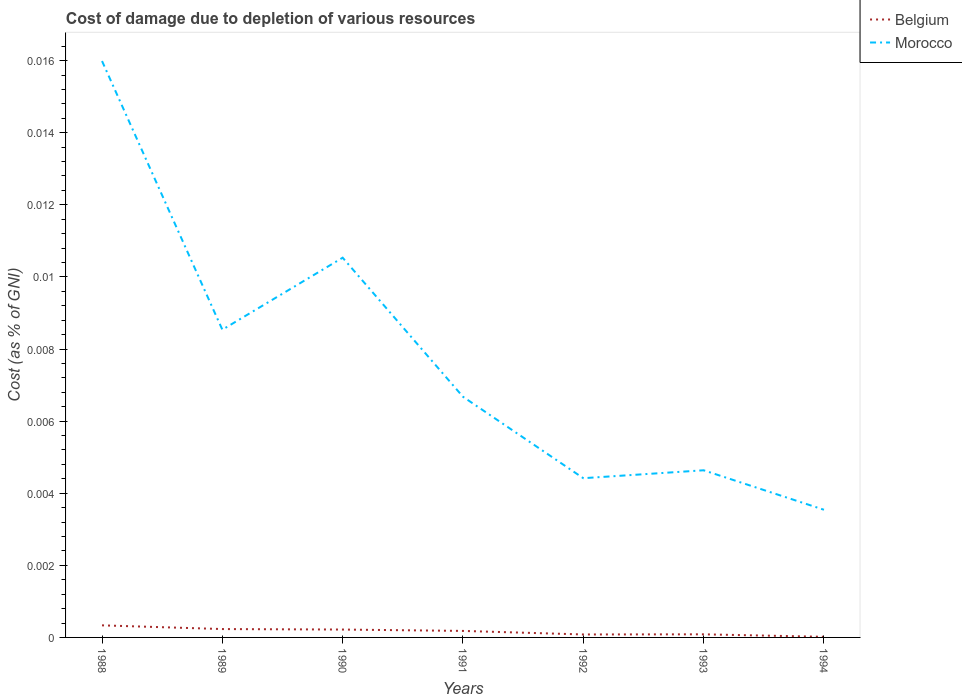Across all years, what is the maximum cost of damage caused due to the depletion of various resources in Belgium?
Provide a succinct answer. 1.66630783874537e-5. What is the total cost of damage caused due to the depletion of various resources in Morocco in the graph?
Give a very brief answer. 0. What is the difference between the highest and the second highest cost of damage caused due to the depletion of various resources in Belgium?
Keep it short and to the point. 0. What is the difference between the highest and the lowest cost of damage caused due to the depletion of various resources in Morocco?
Provide a succinct answer. 3. What is the difference between two consecutive major ticks on the Y-axis?
Offer a very short reply. 0. Does the graph contain any zero values?
Your response must be concise. No. Where does the legend appear in the graph?
Ensure brevity in your answer.  Top right. What is the title of the graph?
Ensure brevity in your answer.  Cost of damage due to depletion of various resources. Does "Zimbabwe" appear as one of the legend labels in the graph?
Ensure brevity in your answer.  No. What is the label or title of the X-axis?
Keep it short and to the point. Years. What is the label or title of the Y-axis?
Provide a short and direct response. Cost (as % of GNI). What is the Cost (as % of GNI) of Belgium in 1988?
Provide a succinct answer. 0. What is the Cost (as % of GNI) of Morocco in 1988?
Keep it short and to the point. 0.02. What is the Cost (as % of GNI) of Belgium in 1989?
Ensure brevity in your answer.  0. What is the Cost (as % of GNI) of Morocco in 1989?
Provide a succinct answer. 0.01. What is the Cost (as % of GNI) in Belgium in 1990?
Offer a very short reply. 0. What is the Cost (as % of GNI) of Morocco in 1990?
Keep it short and to the point. 0.01. What is the Cost (as % of GNI) in Belgium in 1991?
Offer a terse response. 0. What is the Cost (as % of GNI) in Morocco in 1991?
Ensure brevity in your answer.  0.01. What is the Cost (as % of GNI) in Belgium in 1992?
Your answer should be very brief. 8.21367051820707e-5. What is the Cost (as % of GNI) of Morocco in 1992?
Make the answer very short. 0. What is the Cost (as % of GNI) in Belgium in 1993?
Your response must be concise. 8.605214522011529e-5. What is the Cost (as % of GNI) of Morocco in 1993?
Your answer should be very brief. 0. What is the Cost (as % of GNI) of Belgium in 1994?
Make the answer very short. 1.66630783874537e-5. What is the Cost (as % of GNI) in Morocco in 1994?
Offer a very short reply. 0. Across all years, what is the maximum Cost (as % of GNI) in Belgium?
Give a very brief answer. 0. Across all years, what is the maximum Cost (as % of GNI) of Morocco?
Give a very brief answer. 0.02. Across all years, what is the minimum Cost (as % of GNI) in Belgium?
Keep it short and to the point. 1.66630783874537e-5. Across all years, what is the minimum Cost (as % of GNI) in Morocco?
Make the answer very short. 0. What is the total Cost (as % of GNI) in Belgium in the graph?
Your answer should be very brief. 0. What is the total Cost (as % of GNI) in Morocco in the graph?
Make the answer very short. 0.05. What is the difference between the Cost (as % of GNI) of Belgium in 1988 and that in 1989?
Offer a very short reply. 0. What is the difference between the Cost (as % of GNI) of Morocco in 1988 and that in 1989?
Your answer should be very brief. 0.01. What is the difference between the Cost (as % of GNI) of Morocco in 1988 and that in 1990?
Offer a very short reply. 0.01. What is the difference between the Cost (as % of GNI) in Belgium in 1988 and that in 1991?
Offer a very short reply. 0. What is the difference between the Cost (as % of GNI) of Morocco in 1988 and that in 1991?
Ensure brevity in your answer.  0.01. What is the difference between the Cost (as % of GNI) of Belgium in 1988 and that in 1992?
Your response must be concise. 0. What is the difference between the Cost (as % of GNI) in Morocco in 1988 and that in 1992?
Provide a succinct answer. 0.01. What is the difference between the Cost (as % of GNI) in Belgium in 1988 and that in 1993?
Offer a terse response. 0. What is the difference between the Cost (as % of GNI) of Morocco in 1988 and that in 1993?
Give a very brief answer. 0.01. What is the difference between the Cost (as % of GNI) in Morocco in 1988 and that in 1994?
Make the answer very short. 0.01. What is the difference between the Cost (as % of GNI) in Belgium in 1989 and that in 1990?
Keep it short and to the point. 0. What is the difference between the Cost (as % of GNI) of Morocco in 1989 and that in 1990?
Offer a terse response. -0. What is the difference between the Cost (as % of GNI) in Belgium in 1989 and that in 1991?
Offer a very short reply. 0. What is the difference between the Cost (as % of GNI) of Morocco in 1989 and that in 1991?
Offer a very short reply. 0. What is the difference between the Cost (as % of GNI) of Morocco in 1989 and that in 1992?
Offer a terse response. 0. What is the difference between the Cost (as % of GNI) in Belgium in 1989 and that in 1993?
Give a very brief answer. 0. What is the difference between the Cost (as % of GNI) of Morocco in 1989 and that in 1993?
Ensure brevity in your answer.  0. What is the difference between the Cost (as % of GNI) of Belgium in 1989 and that in 1994?
Keep it short and to the point. 0. What is the difference between the Cost (as % of GNI) in Morocco in 1989 and that in 1994?
Offer a very short reply. 0.01. What is the difference between the Cost (as % of GNI) in Morocco in 1990 and that in 1991?
Offer a terse response. 0. What is the difference between the Cost (as % of GNI) in Belgium in 1990 and that in 1992?
Make the answer very short. 0. What is the difference between the Cost (as % of GNI) in Morocco in 1990 and that in 1992?
Offer a terse response. 0.01. What is the difference between the Cost (as % of GNI) of Morocco in 1990 and that in 1993?
Your answer should be very brief. 0.01. What is the difference between the Cost (as % of GNI) of Morocco in 1990 and that in 1994?
Your answer should be compact. 0.01. What is the difference between the Cost (as % of GNI) in Belgium in 1991 and that in 1992?
Your response must be concise. 0. What is the difference between the Cost (as % of GNI) in Morocco in 1991 and that in 1992?
Your response must be concise. 0. What is the difference between the Cost (as % of GNI) of Belgium in 1991 and that in 1993?
Ensure brevity in your answer.  0. What is the difference between the Cost (as % of GNI) of Morocco in 1991 and that in 1993?
Your answer should be very brief. 0. What is the difference between the Cost (as % of GNI) in Belgium in 1991 and that in 1994?
Provide a short and direct response. 0. What is the difference between the Cost (as % of GNI) of Morocco in 1991 and that in 1994?
Ensure brevity in your answer.  0. What is the difference between the Cost (as % of GNI) in Morocco in 1992 and that in 1993?
Provide a succinct answer. -0. What is the difference between the Cost (as % of GNI) of Morocco in 1992 and that in 1994?
Provide a succinct answer. 0. What is the difference between the Cost (as % of GNI) in Belgium in 1993 and that in 1994?
Keep it short and to the point. 0. What is the difference between the Cost (as % of GNI) in Morocco in 1993 and that in 1994?
Ensure brevity in your answer.  0. What is the difference between the Cost (as % of GNI) of Belgium in 1988 and the Cost (as % of GNI) of Morocco in 1989?
Give a very brief answer. -0.01. What is the difference between the Cost (as % of GNI) of Belgium in 1988 and the Cost (as % of GNI) of Morocco in 1990?
Provide a succinct answer. -0.01. What is the difference between the Cost (as % of GNI) of Belgium in 1988 and the Cost (as % of GNI) of Morocco in 1991?
Offer a very short reply. -0.01. What is the difference between the Cost (as % of GNI) in Belgium in 1988 and the Cost (as % of GNI) in Morocco in 1992?
Ensure brevity in your answer.  -0. What is the difference between the Cost (as % of GNI) of Belgium in 1988 and the Cost (as % of GNI) of Morocco in 1993?
Provide a succinct answer. -0. What is the difference between the Cost (as % of GNI) in Belgium in 1988 and the Cost (as % of GNI) in Morocco in 1994?
Offer a very short reply. -0. What is the difference between the Cost (as % of GNI) in Belgium in 1989 and the Cost (as % of GNI) in Morocco in 1990?
Offer a very short reply. -0.01. What is the difference between the Cost (as % of GNI) in Belgium in 1989 and the Cost (as % of GNI) in Morocco in 1991?
Your answer should be compact. -0.01. What is the difference between the Cost (as % of GNI) in Belgium in 1989 and the Cost (as % of GNI) in Morocco in 1992?
Offer a terse response. -0. What is the difference between the Cost (as % of GNI) of Belgium in 1989 and the Cost (as % of GNI) of Morocco in 1993?
Keep it short and to the point. -0. What is the difference between the Cost (as % of GNI) in Belgium in 1989 and the Cost (as % of GNI) in Morocco in 1994?
Give a very brief answer. -0. What is the difference between the Cost (as % of GNI) in Belgium in 1990 and the Cost (as % of GNI) in Morocco in 1991?
Give a very brief answer. -0.01. What is the difference between the Cost (as % of GNI) of Belgium in 1990 and the Cost (as % of GNI) of Morocco in 1992?
Offer a very short reply. -0. What is the difference between the Cost (as % of GNI) of Belgium in 1990 and the Cost (as % of GNI) of Morocco in 1993?
Offer a very short reply. -0. What is the difference between the Cost (as % of GNI) in Belgium in 1990 and the Cost (as % of GNI) in Morocco in 1994?
Provide a succinct answer. -0. What is the difference between the Cost (as % of GNI) of Belgium in 1991 and the Cost (as % of GNI) of Morocco in 1992?
Your response must be concise. -0. What is the difference between the Cost (as % of GNI) of Belgium in 1991 and the Cost (as % of GNI) of Morocco in 1993?
Keep it short and to the point. -0. What is the difference between the Cost (as % of GNI) of Belgium in 1991 and the Cost (as % of GNI) of Morocco in 1994?
Give a very brief answer. -0. What is the difference between the Cost (as % of GNI) of Belgium in 1992 and the Cost (as % of GNI) of Morocco in 1993?
Your answer should be very brief. -0. What is the difference between the Cost (as % of GNI) in Belgium in 1992 and the Cost (as % of GNI) in Morocco in 1994?
Give a very brief answer. -0. What is the difference between the Cost (as % of GNI) of Belgium in 1993 and the Cost (as % of GNI) of Morocco in 1994?
Your response must be concise. -0. What is the average Cost (as % of GNI) in Morocco per year?
Keep it short and to the point. 0.01. In the year 1988, what is the difference between the Cost (as % of GNI) of Belgium and Cost (as % of GNI) of Morocco?
Ensure brevity in your answer.  -0.02. In the year 1989, what is the difference between the Cost (as % of GNI) in Belgium and Cost (as % of GNI) in Morocco?
Ensure brevity in your answer.  -0.01. In the year 1990, what is the difference between the Cost (as % of GNI) of Belgium and Cost (as % of GNI) of Morocco?
Offer a very short reply. -0.01. In the year 1991, what is the difference between the Cost (as % of GNI) in Belgium and Cost (as % of GNI) in Morocco?
Make the answer very short. -0.01. In the year 1992, what is the difference between the Cost (as % of GNI) in Belgium and Cost (as % of GNI) in Morocco?
Provide a succinct answer. -0. In the year 1993, what is the difference between the Cost (as % of GNI) of Belgium and Cost (as % of GNI) of Morocco?
Keep it short and to the point. -0. In the year 1994, what is the difference between the Cost (as % of GNI) of Belgium and Cost (as % of GNI) of Morocco?
Provide a succinct answer. -0. What is the ratio of the Cost (as % of GNI) of Belgium in 1988 to that in 1989?
Your answer should be compact. 1.44. What is the ratio of the Cost (as % of GNI) of Morocco in 1988 to that in 1989?
Your response must be concise. 1.87. What is the ratio of the Cost (as % of GNI) of Belgium in 1988 to that in 1990?
Ensure brevity in your answer.  1.53. What is the ratio of the Cost (as % of GNI) of Morocco in 1988 to that in 1990?
Provide a succinct answer. 1.52. What is the ratio of the Cost (as % of GNI) of Belgium in 1988 to that in 1991?
Make the answer very short. 1.86. What is the ratio of the Cost (as % of GNI) of Morocco in 1988 to that in 1991?
Ensure brevity in your answer.  2.39. What is the ratio of the Cost (as % of GNI) of Belgium in 1988 to that in 1992?
Provide a succinct answer. 4.08. What is the ratio of the Cost (as % of GNI) of Morocco in 1988 to that in 1992?
Offer a terse response. 3.62. What is the ratio of the Cost (as % of GNI) of Belgium in 1988 to that in 1993?
Keep it short and to the point. 3.89. What is the ratio of the Cost (as % of GNI) in Morocco in 1988 to that in 1993?
Offer a very short reply. 3.45. What is the ratio of the Cost (as % of GNI) in Belgium in 1988 to that in 1994?
Your response must be concise. 20.1. What is the ratio of the Cost (as % of GNI) of Morocco in 1988 to that in 1994?
Ensure brevity in your answer.  4.51. What is the ratio of the Cost (as % of GNI) of Belgium in 1989 to that in 1990?
Make the answer very short. 1.06. What is the ratio of the Cost (as % of GNI) in Morocco in 1989 to that in 1990?
Your response must be concise. 0.81. What is the ratio of the Cost (as % of GNI) of Belgium in 1989 to that in 1991?
Provide a short and direct response. 1.29. What is the ratio of the Cost (as % of GNI) of Morocco in 1989 to that in 1991?
Give a very brief answer. 1.28. What is the ratio of the Cost (as % of GNI) of Belgium in 1989 to that in 1992?
Your answer should be compact. 2.83. What is the ratio of the Cost (as % of GNI) of Morocco in 1989 to that in 1992?
Provide a succinct answer. 1.93. What is the ratio of the Cost (as % of GNI) of Belgium in 1989 to that in 1993?
Keep it short and to the point. 2.7. What is the ratio of the Cost (as % of GNI) in Morocco in 1989 to that in 1993?
Ensure brevity in your answer.  1.84. What is the ratio of the Cost (as % of GNI) in Belgium in 1989 to that in 1994?
Make the answer very short. 13.93. What is the ratio of the Cost (as % of GNI) of Morocco in 1989 to that in 1994?
Offer a terse response. 2.41. What is the ratio of the Cost (as % of GNI) of Belgium in 1990 to that in 1991?
Offer a terse response. 1.21. What is the ratio of the Cost (as % of GNI) of Morocco in 1990 to that in 1991?
Your response must be concise. 1.58. What is the ratio of the Cost (as % of GNI) of Belgium in 1990 to that in 1992?
Offer a very short reply. 2.66. What is the ratio of the Cost (as % of GNI) in Morocco in 1990 to that in 1992?
Ensure brevity in your answer.  2.38. What is the ratio of the Cost (as % of GNI) in Belgium in 1990 to that in 1993?
Make the answer very short. 2.54. What is the ratio of the Cost (as % of GNI) in Morocco in 1990 to that in 1993?
Ensure brevity in your answer.  2.27. What is the ratio of the Cost (as % of GNI) of Belgium in 1990 to that in 1994?
Provide a short and direct response. 13.12. What is the ratio of the Cost (as % of GNI) in Morocco in 1990 to that in 1994?
Give a very brief answer. 2.97. What is the ratio of the Cost (as % of GNI) in Belgium in 1991 to that in 1992?
Provide a short and direct response. 2.2. What is the ratio of the Cost (as % of GNI) in Morocco in 1991 to that in 1992?
Your answer should be compact. 1.51. What is the ratio of the Cost (as % of GNI) in Belgium in 1991 to that in 1993?
Offer a very short reply. 2.1. What is the ratio of the Cost (as % of GNI) in Morocco in 1991 to that in 1993?
Ensure brevity in your answer.  1.44. What is the ratio of the Cost (as % of GNI) in Belgium in 1991 to that in 1994?
Give a very brief answer. 10.84. What is the ratio of the Cost (as % of GNI) of Morocco in 1991 to that in 1994?
Your response must be concise. 1.89. What is the ratio of the Cost (as % of GNI) in Belgium in 1992 to that in 1993?
Offer a very short reply. 0.95. What is the ratio of the Cost (as % of GNI) of Morocco in 1992 to that in 1993?
Your response must be concise. 0.95. What is the ratio of the Cost (as % of GNI) in Belgium in 1992 to that in 1994?
Give a very brief answer. 4.93. What is the ratio of the Cost (as % of GNI) of Morocco in 1992 to that in 1994?
Keep it short and to the point. 1.25. What is the ratio of the Cost (as % of GNI) of Belgium in 1993 to that in 1994?
Keep it short and to the point. 5.16. What is the ratio of the Cost (as % of GNI) of Morocco in 1993 to that in 1994?
Give a very brief answer. 1.31. What is the difference between the highest and the second highest Cost (as % of GNI) in Morocco?
Give a very brief answer. 0.01. What is the difference between the highest and the lowest Cost (as % of GNI) of Belgium?
Provide a short and direct response. 0. What is the difference between the highest and the lowest Cost (as % of GNI) of Morocco?
Your answer should be very brief. 0.01. 